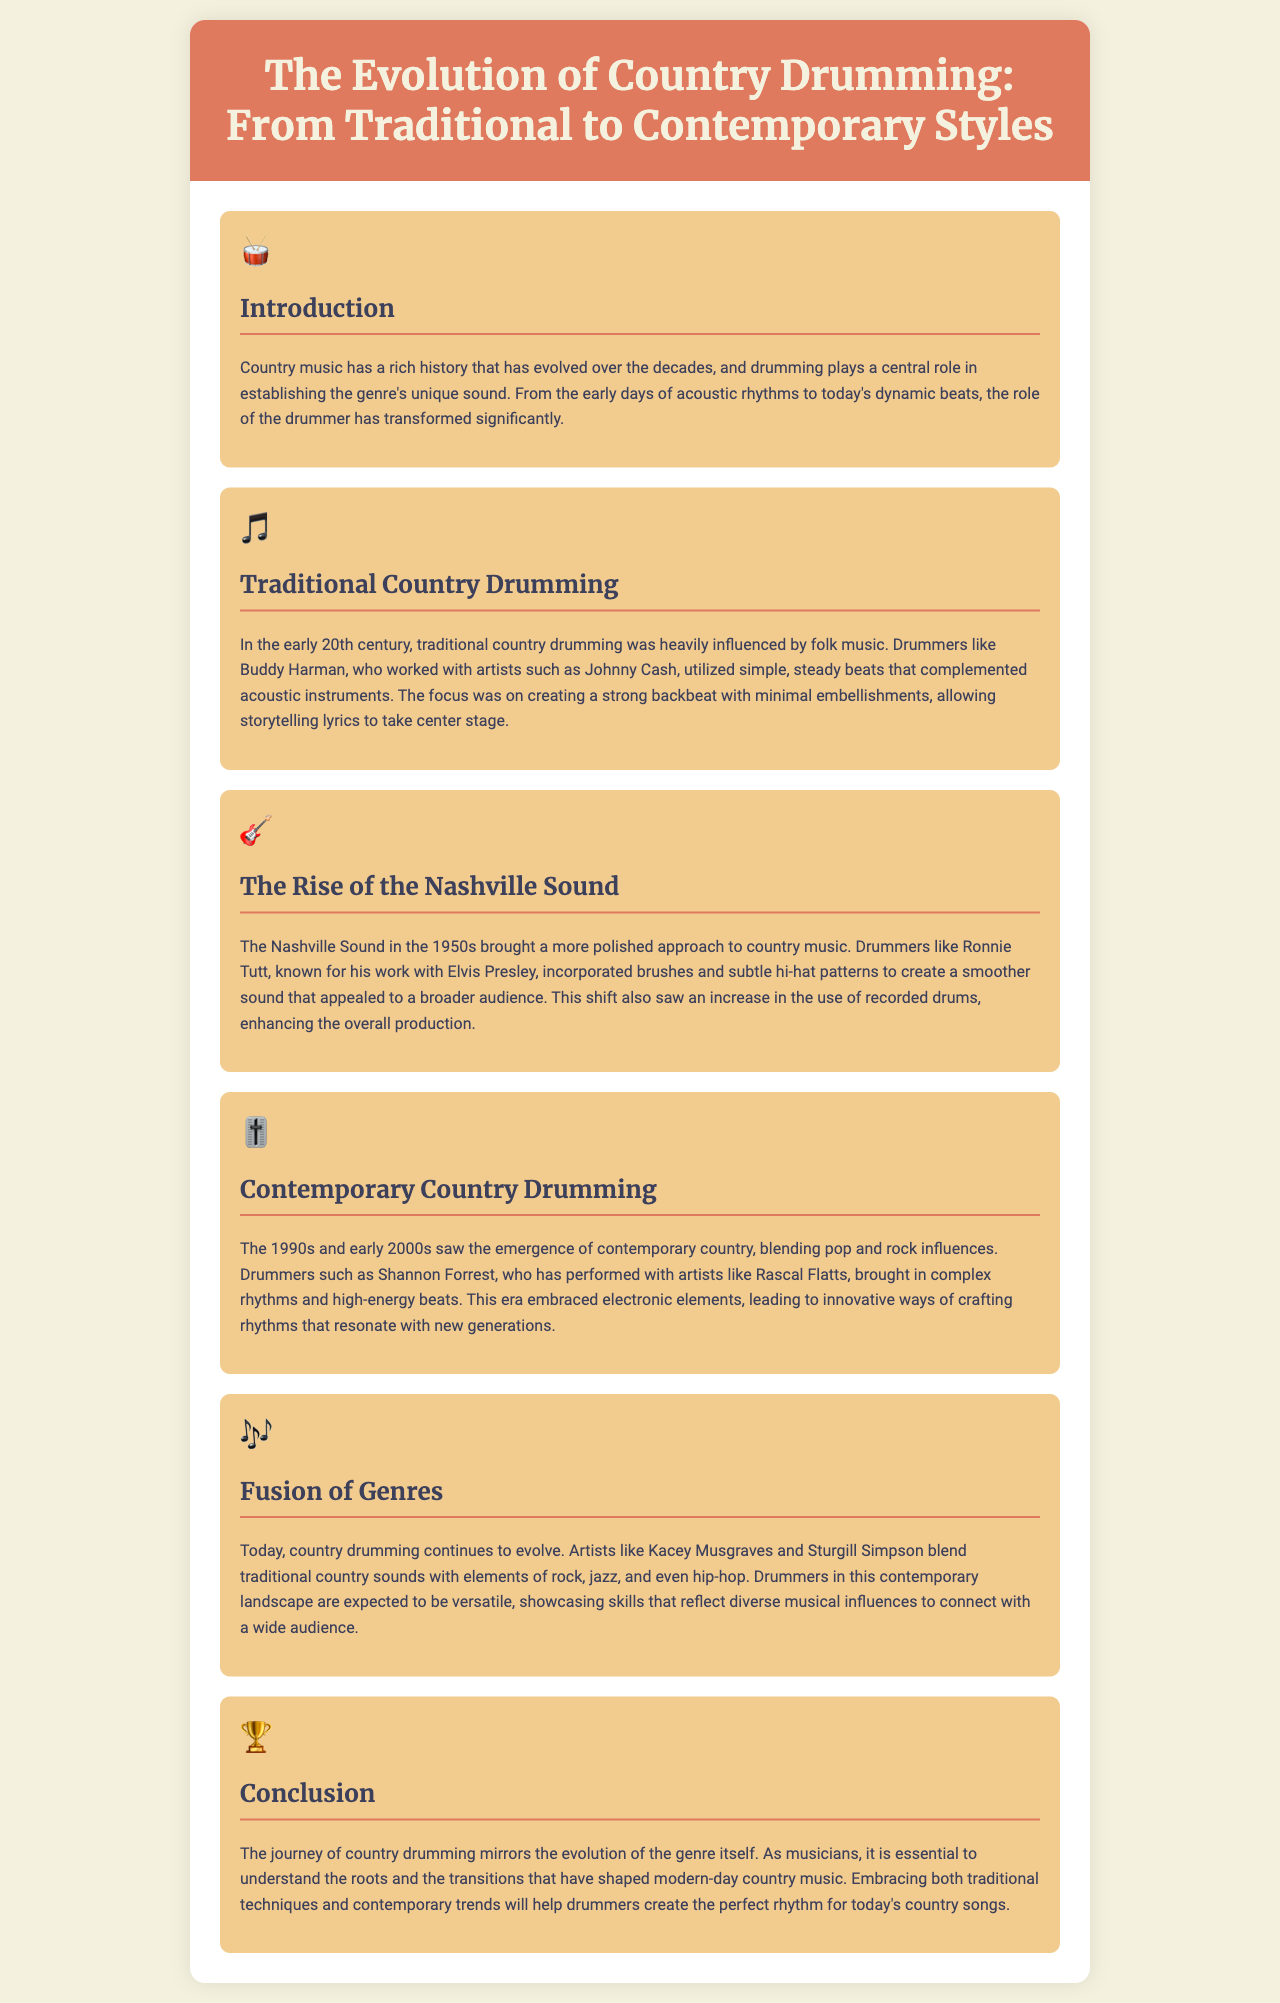what is the primary focus of traditional country drumming? Traditional country drumming focuses on creating a strong backbeat with minimal embellishments.
Answer: strong backbeat who was a notable drummer associated with traditional country drumming? Buddy Harman is mentioned as a notable drummer who worked with artists like Johnny Cash.
Answer: Buddy Harman what musical style influenced contemporary country drumming? The document states that contemporary country drumming blends pop and rock influences.
Answer: pop and rock in what decade did the Nashville Sound emerge? The Nashville Sound emerged in the 1950s.
Answer: 1950s which drummer is known for using brushes and subtle hi-hat patterns? Ronnie Tutt is recognized for his use of brushes and subtle hi-hat patterns.
Answer: Ronnie Tutt what do contemporary drummers in country music need to showcase? Contemporary drummers are expected to showcase skills that reflect diverse musical influences.
Answer: diverse musical influences who are two artists mentioned that blend traditional country with other genres? Kacey Musgraves and Sturgill Simpson blend traditional country sounds with other genres.
Answer: Kacey Musgraves and Sturgill Simpson what is emphasized in the conclusion of the brochure? The conclusion emphasizes understanding the roots and transitions that have shaped modern-day country music.
Answer: understanding the roots and transitions 